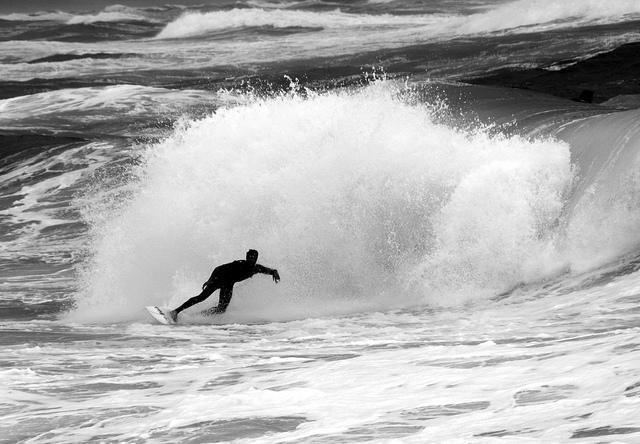How many cars have their lights on?
Give a very brief answer. 0. 